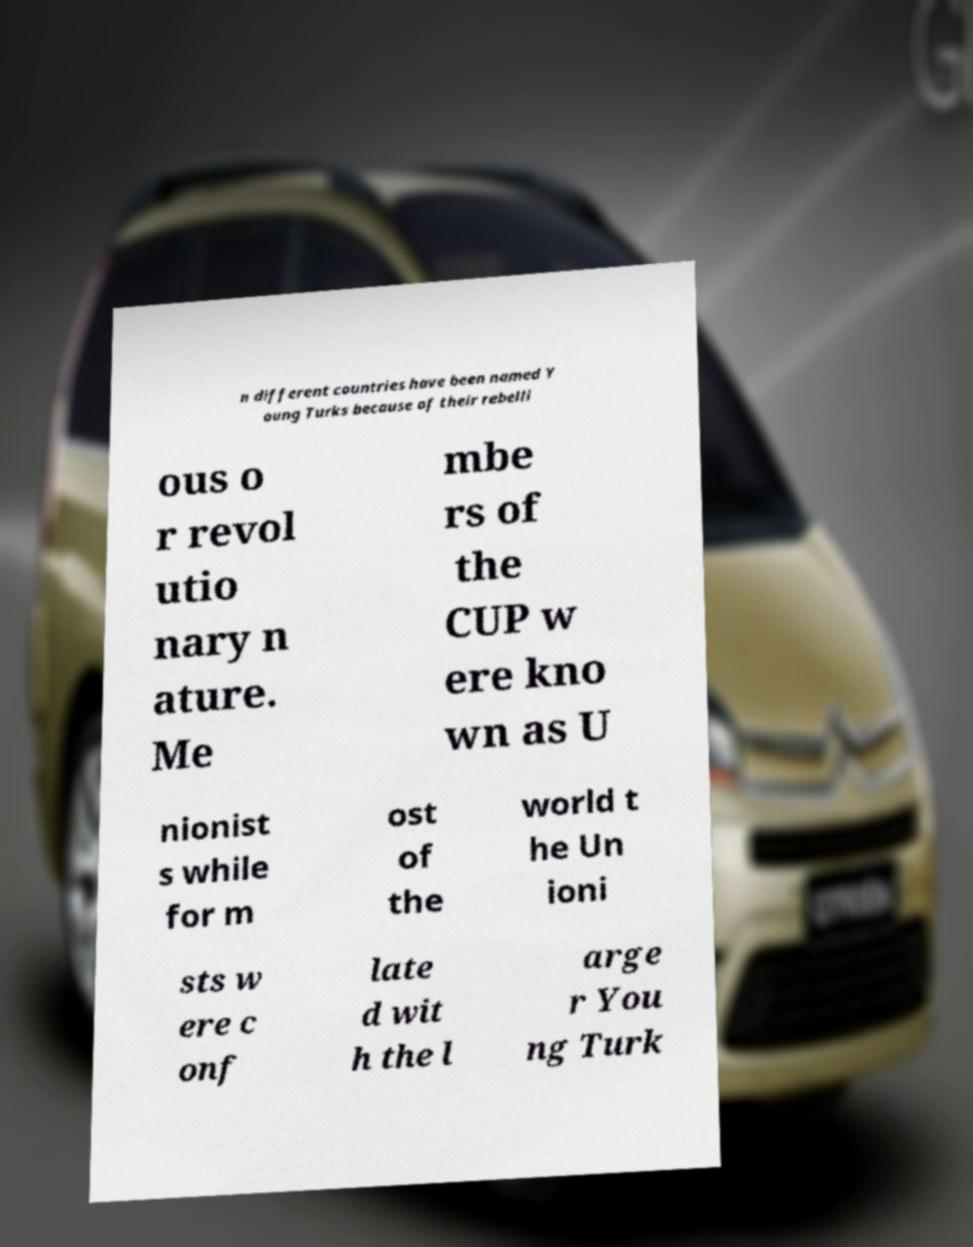Can you read and provide the text displayed in the image?This photo seems to have some interesting text. Can you extract and type it out for me? n different countries have been named Y oung Turks because of their rebelli ous o r revol utio nary n ature. Me mbe rs of the CUP w ere kno wn as U nionist s while for m ost of the world t he Un ioni sts w ere c onf late d wit h the l arge r You ng Turk 